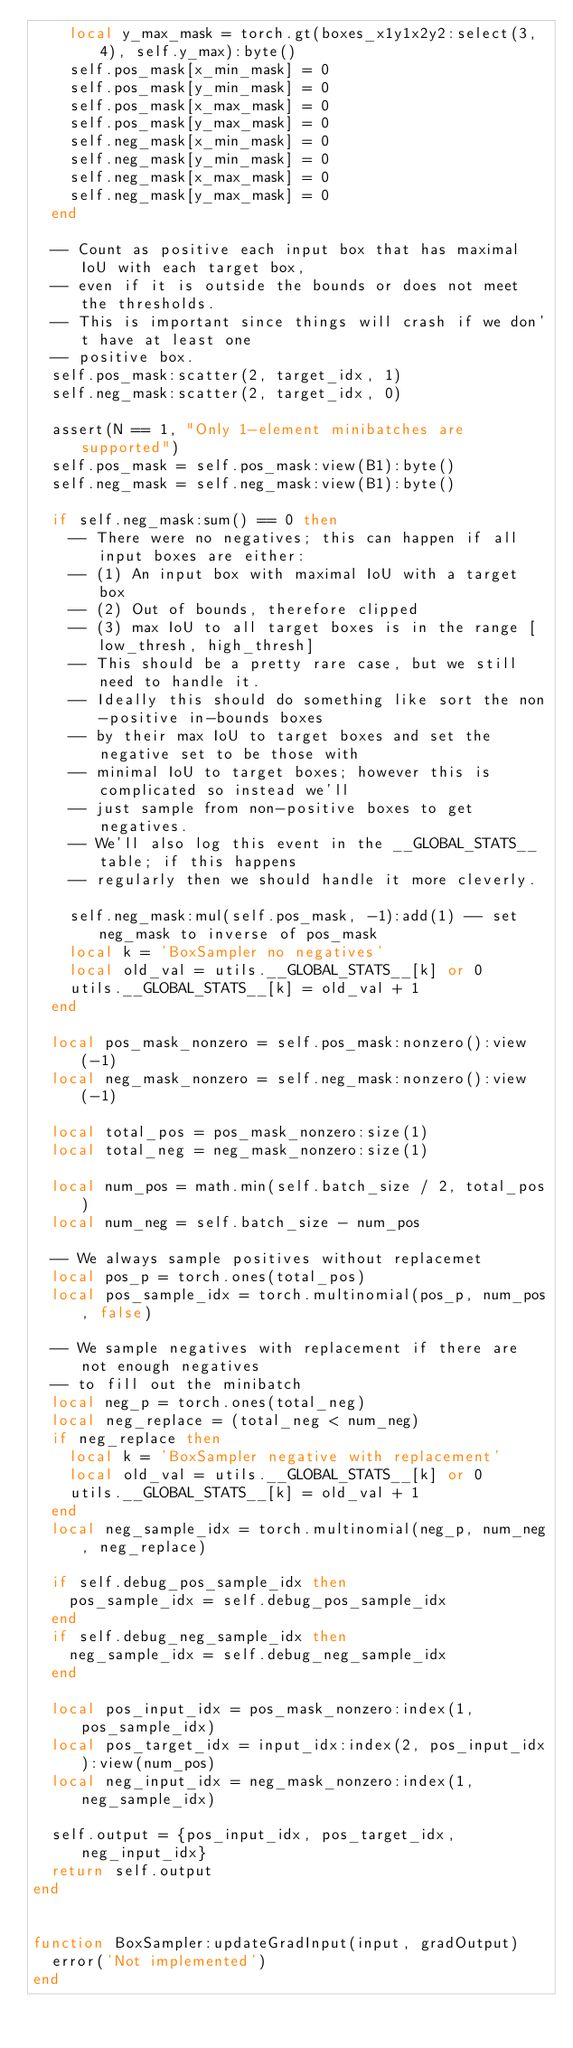<code> <loc_0><loc_0><loc_500><loc_500><_Lua_>    local y_max_mask = torch.gt(boxes_x1y1x2y2:select(3, 4), self.y_max):byte()
    self.pos_mask[x_min_mask] = 0
    self.pos_mask[y_min_mask] = 0
    self.pos_mask[x_max_mask] = 0
    self.pos_mask[y_max_mask] = 0
    self.neg_mask[x_min_mask] = 0
    self.neg_mask[y_min_mask] = 0
    self.neg_mask[x_max_mask] = 0
    self.neg_mask[y_max_mask] = 0
  end

  -- Count as positive each input box that has maximal IoU with each target box,
  -- even if it is outside the bounds or does not meet the thresholds.
  -- This is important since things will crash if we don't have at least one
  -- positive box.
  self.pos_mask:scatter(2, target_idx, 1)
  self.neg_mask:scatter(2, target_idx, 0)

  assert(N == 1, "Only 1-element minibatches are supported")
  self.pos_mask = self.pos_mask:view(B1):byte()
  self.neg_mask = self.neg_mask:view(B1):byte()

  if self.neg_mask:sum() == 0 then
    -- There were no negatives; this can happen if all input boxes are either:
    -- (1) An input box with maximal IoU with a target box
    -- (2) Out of bounds, therefore clipped
    -- (3) max IoU to all target boxes is in the range [low_thresh, high_thresh]
    -- This should be a pretty rare case, but we still need to handle it.
    -- Ideally this should do something like sort the non-positive in-bounds boxes
    -- by their max IoU to target boxes and set the negative set to be those with
    -- minimal IoU to target boxes; however this is complicated so instead we'll
    -- just sample from non-positive boxes to get negatives.
    -- We'll also log this event in the __GLOBAL_STATS__ table; if this happens
    -- regularly then we should handle it more cleverly.

    self.neg_mask:mul(self.pos_mask, -1):add(1) -- set neg_mask to inverse of pos_mask
    local k = 'BoxSampler no negatives'
    local old_val = utils.__GLOBAL_STATS__[k] or 0
    utils.__GLOBAL_STATS__[k] = old_val + 1
  end

  local pos_mask_nonzero = self.pos_mask:nonzero():view(-1)
  local neg_mask_nonzero = self.neg_mask:nonzero():view(-1)

  local total_pos = pos_mask_nonzero:size(1)
  local total_neg = neg_mask_nonzero:size(1)

  local num_pos = math.min(self.batch_size / 2, total_pos)
  local num_neg = self.batch_size - num_pos

  -- We always sample positives without replacemet
  local pos_p = torch.ones(total_pos)
  local pos_sample_idx = torch.multinomial(pos_p, num_pos, false)

  -- We sample negatives with replacement if there are not enough negatives
  -- to fill out the minibatch
  local neg_p = torch.ones(total_neg)
  local neg_replace = (total_neg < num_neg)
  if neg_replace then
    local k = 'BoxSampler negative with replacement'
    local old_val = utils.__GLOBAL_STATS__[k] or 0
    utils.__GLOBAL_STATS__[k] = old_val + 1
  end
  local neg_sample_idx = torch.multinomial(neg_p, num_neg, neg_replace)
  
  if self.debug_pos_sample_idx then
    pos_sample_idx = self.debug_pos_sample_idx
  end
  if self.debug_neg_sample_idx then
    neg_sample_idx = self.debug_neg_sample_idx
  end

  local pos_input_idx = pos_mask_nonzero:index(1, pos_sample_idx)
  local pos_target_idx = input_idx:index(2, pos_input_idx):view(num_pos)
  local neg_input_idx = neg_mask_nonzero:index(1, neg_sample_idx)
  
  self.output = {pos_input_idx, pos_target_idx, neg_input_idx}
  return self.output
end


function BoxSampler:updateGradInput(input, gradOutput)
  error('Not implemented')
end
</code> 